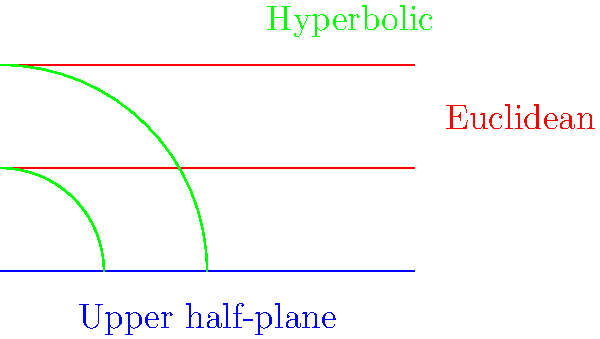In the upper half-plane model of hyperbolic geometry, parallel lines exhibit a unique behavior compared to Euclidean geometry. How do the red and green lines in the diagram differ in their representation of parallel lines, and what does this imply about the nature of space in hyperbolic geometry? To understand the difference between parallel lines in Euclidean and hyperbolic geometry, let's break it down step-by-step:

1. Euclidean parallel lines (red):
   - These are straight lines that maintain a constant distance from each other.
   - They never intersect, no matter how far they are extended.
   - In the diagram, they appear as horizontal straight lines.

2. Hyperbolic parallel lines (green):
   - In the upper half-plane model, these are represented by semicircles centered on the x-axis.
   - They diverge from each other as they approach the boundary (x-axis) of the model.
   - The further they extend, the greater the distance between them becomes.

3. Implications for hyperbolic space:
   - In hyperbolic geometry, parallel lines behave differently than in Euclidean geometry.
   - The divergence of parallel lines implies that space in hyperbolic geometry is "curved" or "negatively curved."
   - This curvature affects the sum of angles in triangles, which is less than 180 degrees in hyperbolic geometry.

4. Connection to the upper half-plane model:
   - The blue line represents the boundary of the upper half-plane model.
   - All points above this line represent the hyperbolic plane.
   - The model preserves angles but distorts distances, especially near the boundary.

5. Relevance to non-Euclidean geometry:
   - This comparison demonstrates that the parallel postulate of Euclidean geometry does not hold in hyperbolic geometry.
   - It showcases how different geometric systems can arise from altering fundamental axioms.

The diagram visually represents these concepts, highlighting the stark difference between parallel lines in Euclidean and hyperbolic geometries within the context of the upper half-plane model.
Answer: Euclidean parallels remain equidistant; hyperbolic parallels diverge, implying curved space. 